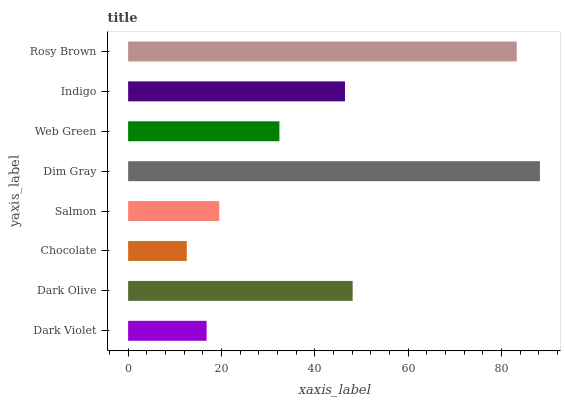Is Chocolate the minimum?
Answer yes or no. Yes. Is Dim Gray the maximum?
Answer yes or no. Yes. Is Dark Olive the minimum?
Answer yes or no. No. Is Dark Olive the maximum?
Answer yes or no. No. Is Dark Olive greater than Dark Violet?
Answer yes or no. Yes. Is Dark Violet less than Dark Olive?
Answer yes or no. Yes. Is Dark Violet greater than Dark Olive?
Answer yes or no. No. Is Dark Olive less than Dark Violet?
Answer yes or no. No. Is Indigo the high median?
Answer yes or no. Yes. Is Web Green the low median?
Answer yes or no. Yes. Is Rosy Brown the high median?
Answer yes or no. No. Is Dark Violet the low median?
Answer yes or no. No. 